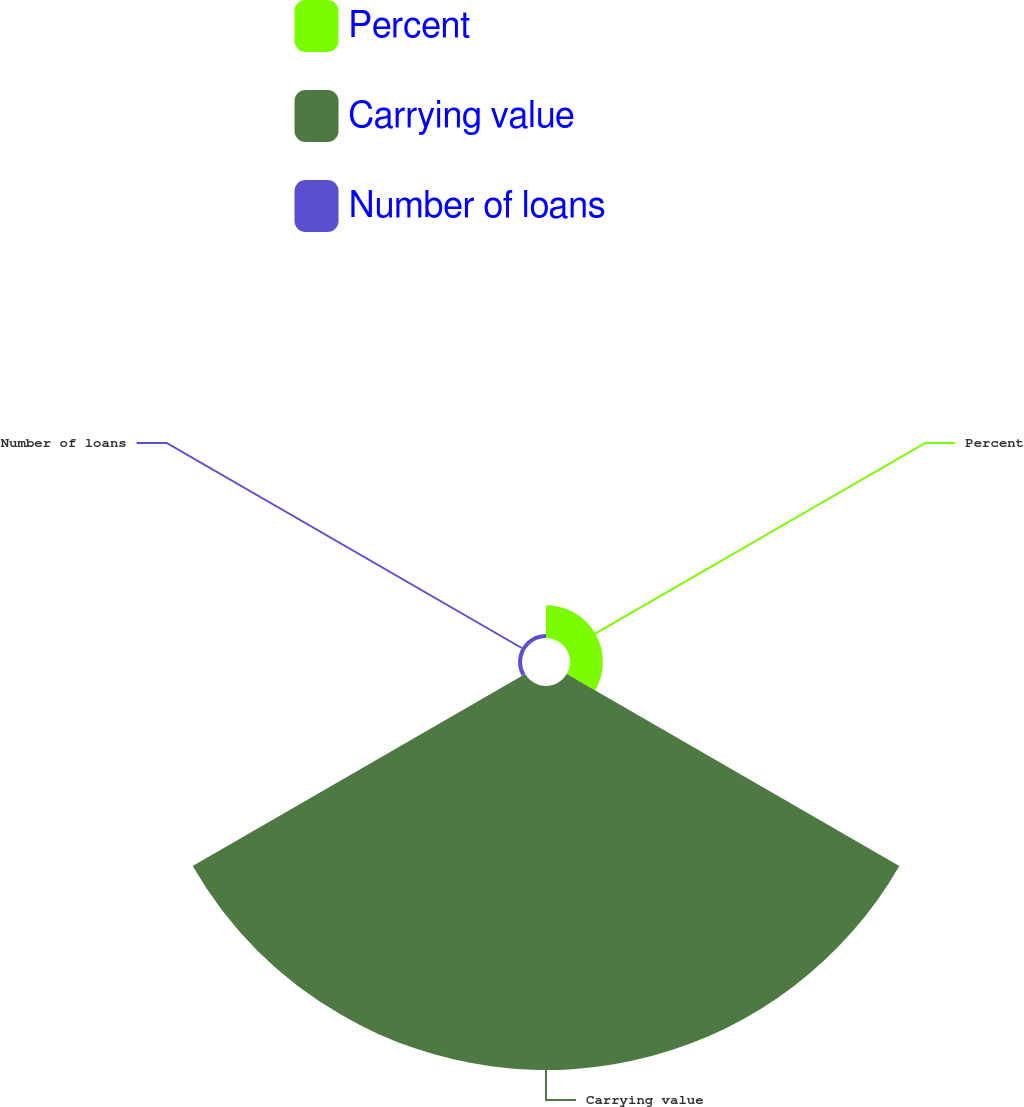<chart> <loc_0><loc_0><loc_500><loc_500><pie_chart><fcel>Percent<fcel>Carrying value<fcel>Number of loans<nl><fcel>7.81%<fcel>91.24%<fcel>0.95%<nl></chart> 